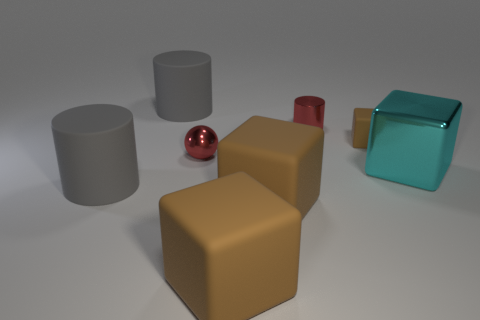Subtract all gray balls. How many gray cylinders are left? 2 Subtract all brown blocks. How many blocks are left? 1 Subtract all cyan cubes. How many cubes are left? 3 Add 2 cyan metal things. How many objects exist? 10 Subtract 1 cubes. How many cubes are left? 3 Subtract all spheres. How many objects are left? 7 Subtract all brown cylinders. Subtract all purple cubes. How many cylinders are left? 3 Add 6 red metal things. How many red metal things exist? 8 Subtract 0 blue blocks. How many objects are left? 8 Subtract all matte things. Subtract all yellow rubber cylinders. How many objects are left? 3 